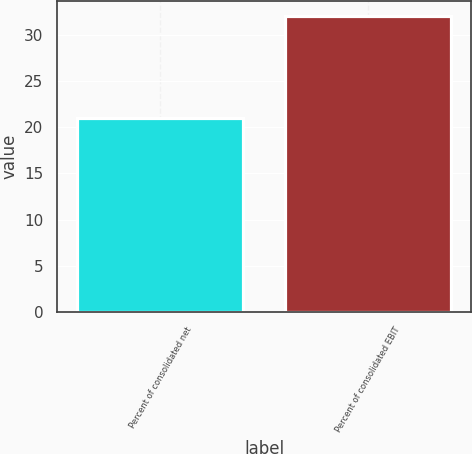Convert chart. <chart><loc_0><loc_0><loc_500><loc_500><bar_chart><fcel>Percent of consolidated net<fcel>Percent of consolidated EBIT<nl><fcel>21<fcel>32<nl></chart> 